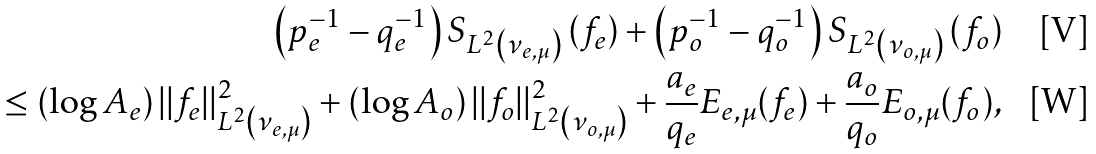Convert formula to latex. <formula><loc_0><loc_0><loc_500><loc_500>\left ( p _ { e } ^ { - 1 } - q _ { e } ^ { - 1 } \right ) S _ { L ^ { 2 } \left ( \nu _ { e , \mu } \right ) } \left ( f _ { e } \right ) + \left ( p _ { o } ^ { - 1 } - q _ { o } ^ { - 1 } \right ) S _ { L ^ { 2 } \left ( \nu _ { o , \mu } \right ) } \left ( f _ { o } \right ) \\ \leq \left ( \log A _ { e } \right ) | | f _ { e } | | ^ { 2 } _ { L ^ { 2 } \left ( \nu _ { e , \mu } \right ) } + \left ( \log A _ { o } \right ) | | f _ { o } | | ^ { 2 } _ { L ^ { 2 } \left ( \nu _ { o , \mu } \right ) } + \frac { a _ { e } } { q _ { e } } E _ { e , \mu } ( f _ { e } ) + \frac { a _ { o } } { q _ { o } } E _ { o , \mu } ( f _ { o } ) ,</formula> 